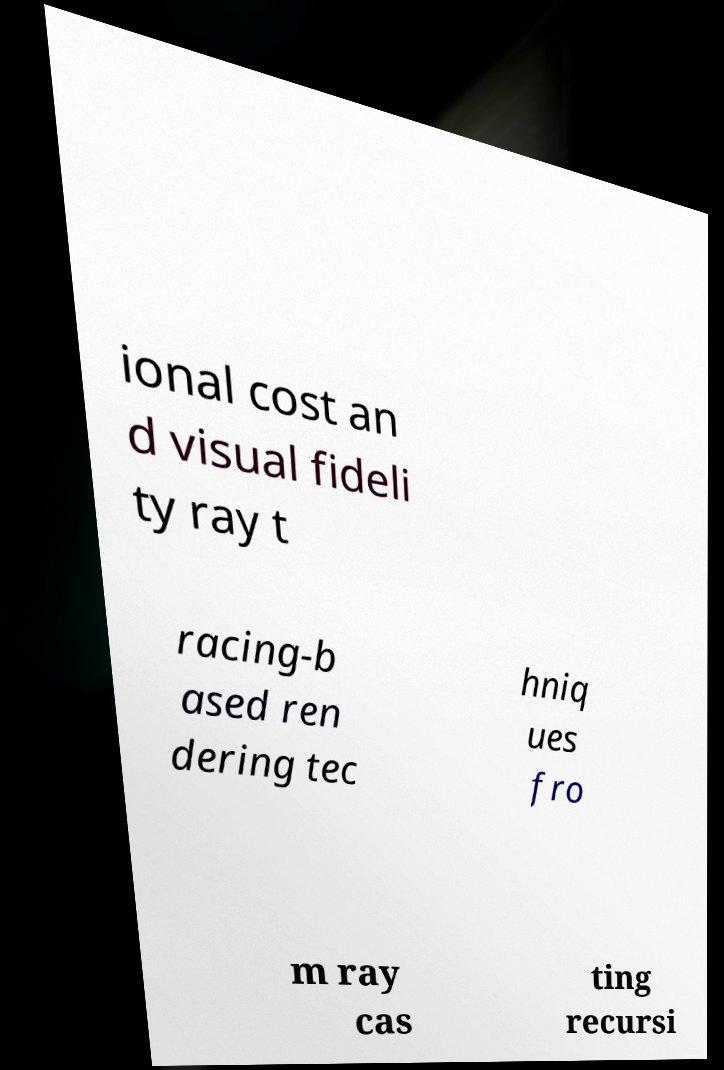I need the written content from this picture converted into text. Can you do that? ional cost an d visual fideli ty ray t racing-b ased ren dering tec hniq ues fro m ray cas ting recursi 